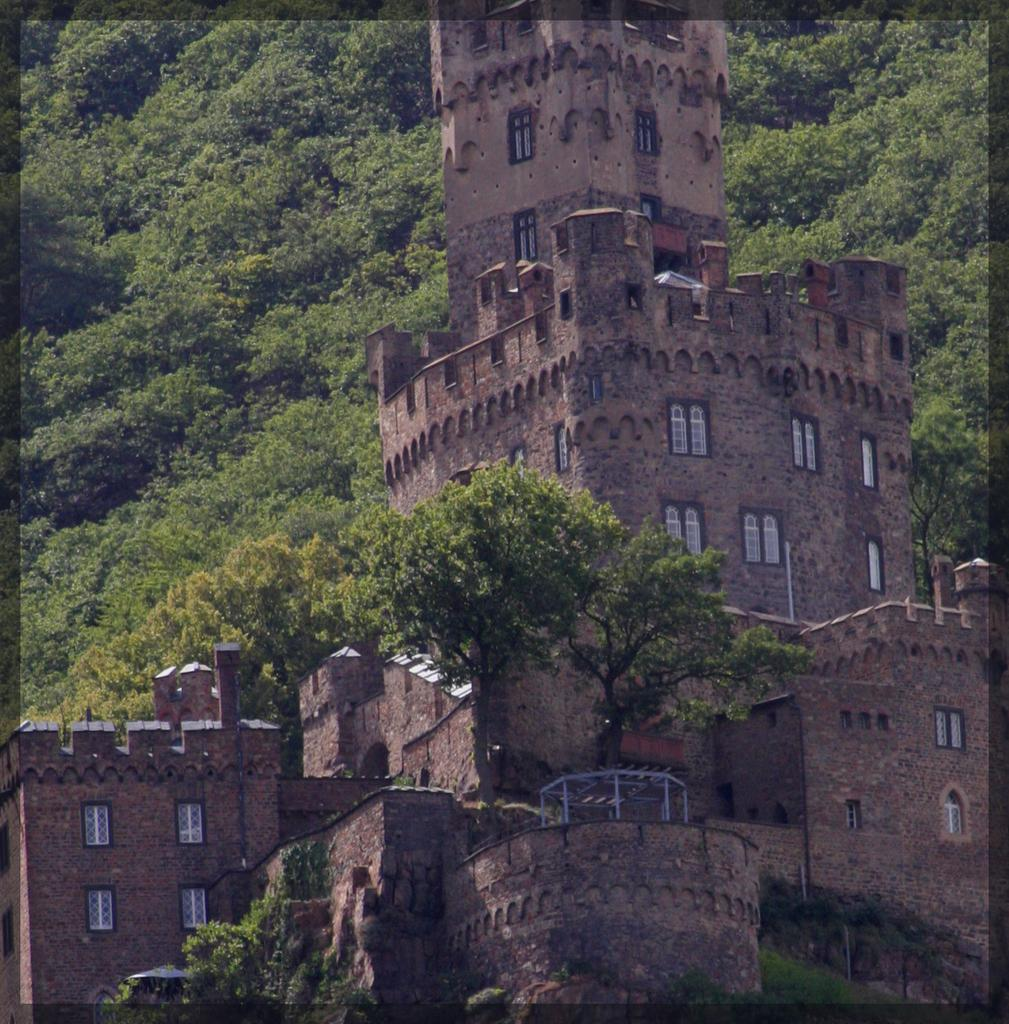What is the main structure in the image? There is a castle in the image. Can you describe the castle's appearance? The castle has many windows in the front. What can be seen in the background of the image? There are trees in the background of the image. Where is the dock located in the image? There is no dock present in the image. Can you tell me how many donkeys are grazing near the castle? There are no donkeys present in the image. 